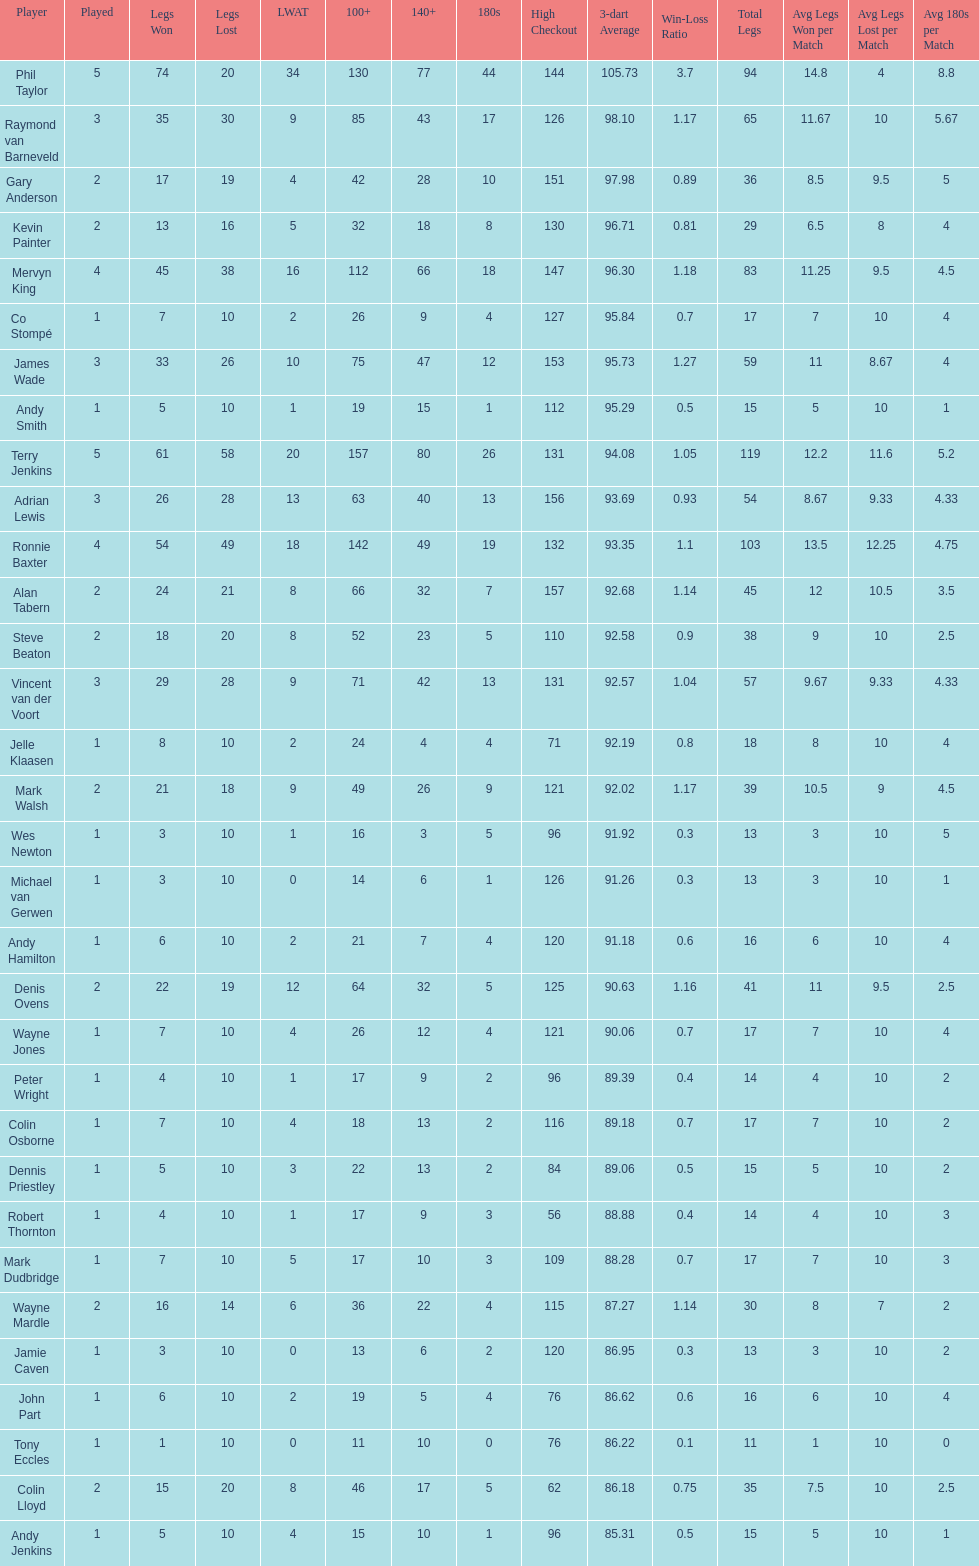Which player has his high checkout as 116? Colin Osborne. 